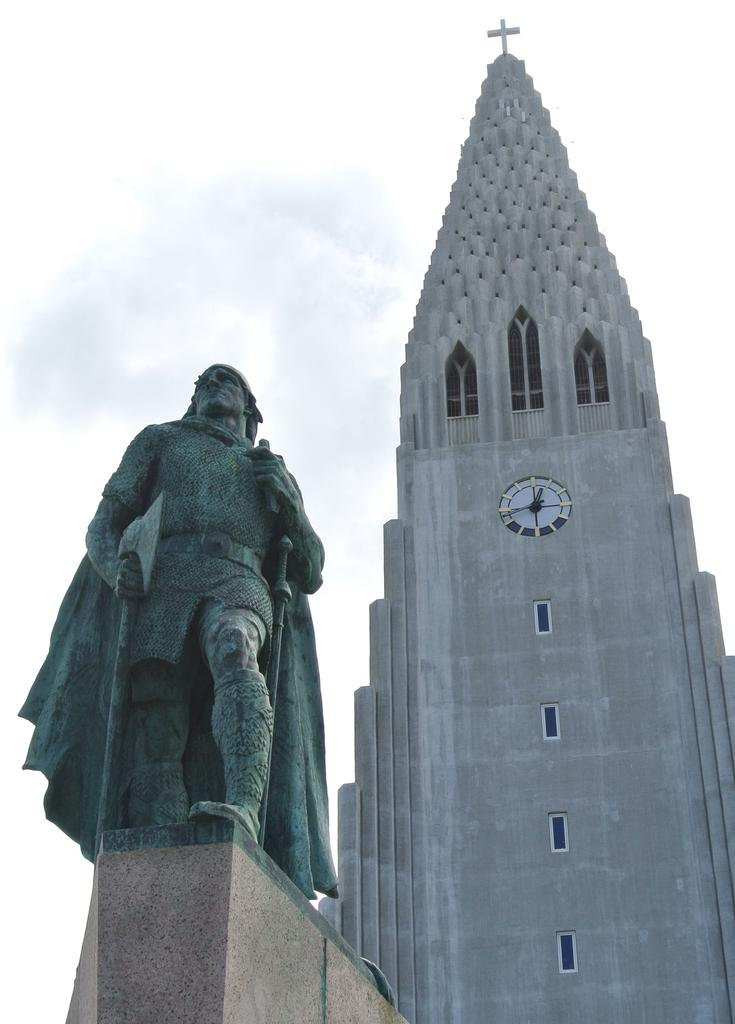What is the main subject in the image? There is a statue in the image. How is the statue positioned in the image? The statue is on a pedestal. What can be seen in the background of the image? There is a tower and the sky visible in the background of the image. How many women are standing in line in front of the statue in the image? There are no women or lines present in the image; it features a statue on a pedestal with a tower and the sky visible in the background. 